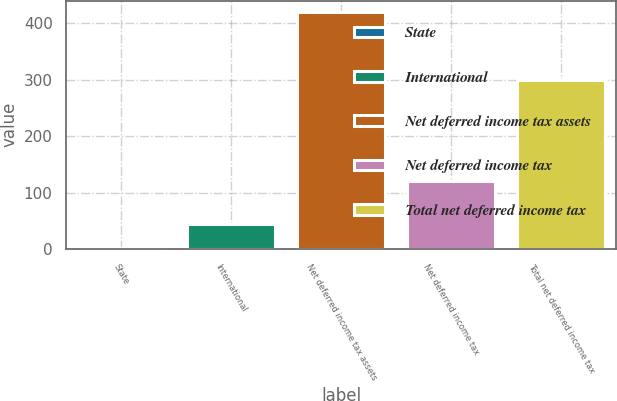Convert chart. <chart><loc_0><loc_0><loc_500><loc_500><bar_chart><fcel>State<fcel>International<fcel>Net deferred income tax assets<fcel>Net deferred income tax<fcel>Total net deferred income tax<nl><fcel>2.6<fcel>44.23<fcel>418.9<fcel>120.2<fcel>298.7<nl></chart> 